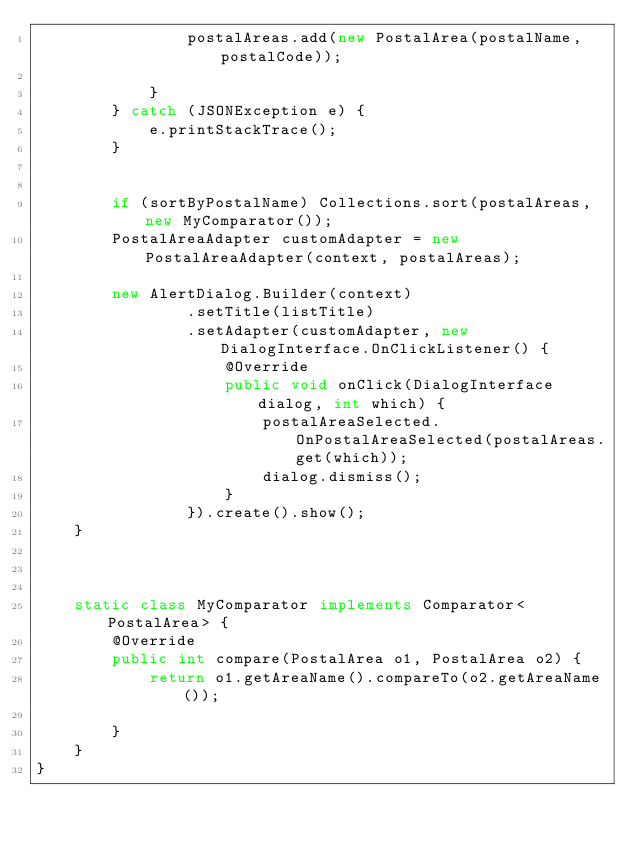Convert code to text. <code><loc_0><loc_0><loc_500><loc_500><_Java_>                postalAreas.add(new PostalArea(postalName, postalCode));

            }
        } catch (JSONException e) {
            e.printStackTrace();
        }


        if (sortByPostalName) Collections.sort(postalAreas, new MyComparator());
        PostalAreaAdapter customAdapter = new PostalAreaAdapter(context, postalAreas);

        new AlertDialog.Builder(context)
                .setTitle(listTitle)
                .setAdapter(customAdapter, new DialogInterface.OnClickListener() {
                    @Override
                    public void onClick(DialogInterface dialog, int which) {
                        postalAreaSelected.OnPostalAreaSelected(postalAreas.get(which));
                        dialog.dismiss();
                    }
                }).create().show();
    }



    static class MyComparator implements Comparator<PostalArea> {
        @Override
        public int compare(PostalArea o1, PostalArea o2) {
            return o1.getAreaName().compareTo(o2.getAreaName());

        }
    }
}
</code> 